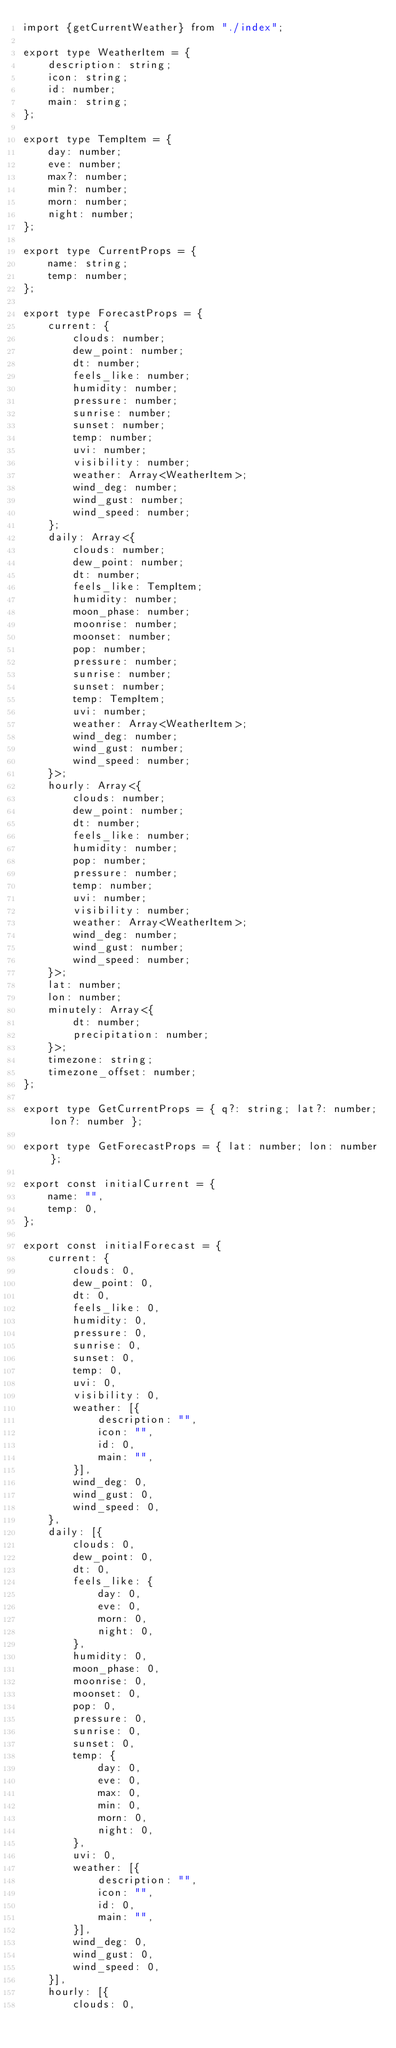Convert code to text. <code><loc_0><loc_0><loc_500><loc_500><_TypeScript_>import {getCurrentWeather} from "./index";

export type WeatherItem = {
    description: string;
    icon: string;
    id: number;
    main: string;
};

export type TempItem = {
    day: number;
    eve: number;
    max?: number;
    min?: number;
    morn: number;
    night: number;
};

export type CurrentProps = {
    name: string;
    temp: number;
};

export type ForecastProps = {
    current: {
        clouds: number;
        dew_point: number;
        dt: number;
        feels_like: number;
        humidity: number;
        pressure: number;
        sunrise: number;
        sunset: number;
        temp: number;
        uvi: number;
        visibility: number;
        weather: Array<WeatherItem>;
        wind_deg: number;
        wind_gust: number;
        wind_speed: number;
    };
    daily: Array<{
        clouds: number;
        dew_point: number;
        dt: number;
        feels_like: TempItem;
        humidity: number;
        moon_phase: number;
        moonrise: number;
        moonset: number;
        pop: number;
        pressure: number;
        sunrise: number;
        sunset: number;
        temp: TempItem;
        uvi: number;
        weather: Array<WeatherItem>;
        wind_deg: number;
        wind_gust: number;
        wind_speed: number;
    }>;
    hourly: Array<{
        clouds: number;
        dew_point: number;
        dt: number;
        feels_like: number;
        humidity: number;
        pop: number;
        pressure: number;
        temp: number;
        uvi: number;
        visibility: number;
        weather: Array<WeatherItem>;
        wind_deg: number;
        wind_gust: number;
        wind_speed: number;
    }>;
    lat: number;
    lon: number;
    minutely: Array<{
        dt: number;
        precipitation: number;
    }>;
    timezone: string;
    timezone_offset: number;
};

export type GetCurrentProps = { q?: string; lat?: number; lon?: number };

export type GetForecastProps = { lat: number; lon: number };

export const initialCurrent = {
    name: "",
    temp: 0,
};

export const initialForecast = {
    current: {
        clouds: 0,
        dew_point: 0,
        dt: 0,
        feels_like: 0,
        humidity: 0,
        pressure: 0,
        sunrise: 0,
        sunset: 0,
        temp: 0,
        uvi: 0,
        visibility: 0,
        weather: [{
            description: "",
            icon: "",
            id: 0,
            main: "",
        }],
        wind_deg: 0,
        wind_gust: 0,
        wind_speed: 0,
    },
    daily: [{
        clouds: 0,
        dew_point: 0,
        dt: 0,
        feels_like: {
            day: 0,
            eve: 0,
            morn: 0,
            night: 0,
        },
        humidity: 0,
        moon_phase: 0,
        moonrise: 0,
        moonset: 0,
        pop: 0,
        pressure: 0,
        sunrise: 0,
        sunset: 0,
        temp: {
            day: 0,
            eve: 0,
            max: 0,
            min: 0,
            morn: 0,
            night: 0,
        },
        uvi: 0,
        weather: [{
            description: "",
            icon: "",
            id: 0,
            main: "",
        }],
        wind_deg: 0,
        wind_gust: 0,
        wind_speed: 0,
    }],
    hourly: [{
        clouds: 0,</code> 